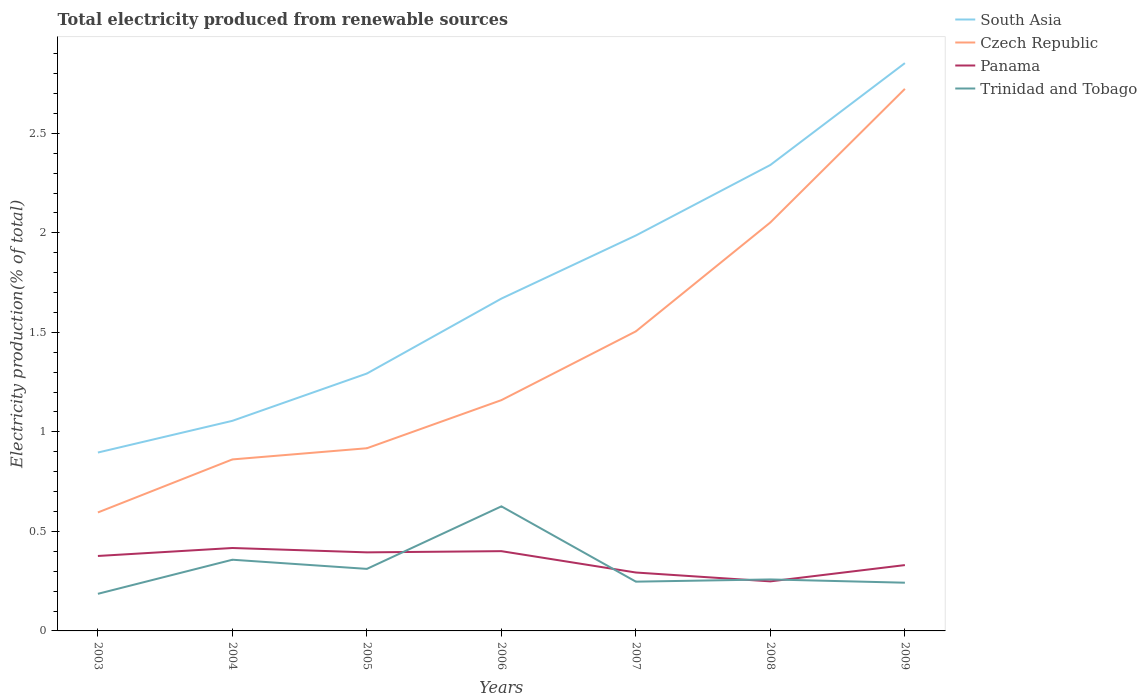How many different coloured lines are there?
Your answer should be compact. 4. Does the line corresponding to Panama intersect with the line corresponding to Czech Republic?
Provide a short and direct response. No. Across all years, what is the maximum total electricity produced in Trinidad and Tobago?
Your response must be concise. 0.19. What is the total total electricity produced in Panama in the graph?
Give a very brief answer. -0.02. What is the difference between the highest and the second highest total electricity produced in Panama?
Your answer should be compact. 0.17. Are the values on the major ticks of Y-axis written in scientific E-notation?
Provide a succinct answer. No. Does the graph contain any zero values?
Provide a succinct answer. No. Where does the legend appear in the graph?
Ensure brevity in your answer.  Top right. What is the title of the graph?
Give a very brief answer. Total electricity produced from renewable sources. What is the label or title of the X-axis?
Offer a very short reply. Years. What is the label or title of the Y-axis?
Your answer should be very brief. Electricity production(% of total). What is the Electricity production(% of total) of South Asia in 2003?
Your response must be concise. 0.9. What is the Electricity production(% of total) in Czech Republic in 2003?
Your answer should be compact. 0.6. What is the Electricity production(% of total) of Panama in 2003?
Provide a short and direct response. 0.38. What is the Electricity production(% of total) of Trinidad and Tobago in 2003?
Offer a very short reply. 0.19. What is the Electricity production(% of total) of South Asia in 2004?
Offer a very short reply. 1.06. What is the Electricity production(% of total) in Czech Republic in 2004?
Offer a very short reply. 0.86. What is the Electricity production(% of total) in Panama in 2004?
Your answer should be compact. 0.42. What is the Electricity production(% of total) in Trinidad and Tobago in 2004?
Your answer should be compact. 0.36. What is the Electricity production(% of total) of South Asia in 2005?
Your answer should be compact. 1.29. What is the Electricity production(% of total) in Czech Republic in 2005?
Provide a succinct answer. 0.92. What is the Electricity production(% of total) of Panama in 2005?
Provide a succinct answer. 0.39. What is the Electricity production(% of total) in Trinidad and Tobago in 2005?
Keep it short and to the point. 0.31. What is the Electricity production(% of total) in South Asia in 2006?
Offer a very short reply. 1.67. What is the Electricity production(% of total) in Czech Republic in 2006?
Offer a very short reply. 1.16. What is the Electricity production(% of total) in Panama in 2006?
Your answer should be very brief. 0.4. What is the Electricity production(% of total) of Trinidad and Tobago in 2006?
Your answer should be compact. 0.63. What is the Electricity production(% of total) of South Asia in 2007?
Provide a short and direct response. 1.99. What is the Electricity production(% of total) of Czech Republic in 2007?
Your answer should be compact. 1.51. What is the Electricity production(% of total) in Panama in 2007?
Ensure brevity in your answer.  0.29. What is the Electricity production(% of total) in Trinidad and Tobago in 2007?
Give a very brief answer. 0.25. What is the Electricity production(% of total) of South Asia in 2008?
Give a very brief answer. 2.34. What is the Electricity production(% of total) in Czech Republic in 2008?
Offer a terse response. 2.05. What is the Electricity production(% of total) of Panama in 2008?
Give a very brief answer. 0.25. What is the Electricity production(% of total) in Trinidad and Tobago in 2008?
Your answer should be very brief. 0.26. What is the Electricity production(% of total) in South Asia in 2009?
Offer a very short reply. 2.85. What is the Electricity production(% of total) of Czech Republic in 2009?
Give a very brief answer. 2.72. What is the Electricity production(% of total) in Panama in 2009?
Make the answer very short. 0.33. What is the Electricity production(% of total) in Trinidad and Tobago in 2009?
Offer a very short reply. 0.24. Across all years, what is the maximum Electricity production(% of total) of South Asia?
Make the answer very short. 2.85. Across all years, what is the maximum Electricity production(% of total) of Czech Republic?
Provide a short and direct response. 2.72. Across all years, what is the maximum Electricity production(% of total) of Panama?
Offer a terse response. 0.42. Across all years, what is the maximum Electricity production(% of total) of Trinidad and Tobago?
Your answer should be compact. 0.63. Across all years, what is the minimum Electricity production(% of total) of South Asia?
Your answer should be very brief. 0.9. Across all years, what is the minimum Electricity production(% of total) of Czech Republic?
Provide a short and direct response. 0.6. Across all years, what is the minimum Electricity production(% of total) in Panama?
Offer a very short reply. 0.25. Across all years, what is the minimum Electricity production(% of total) of Trinidad and Tobago?
Provide a short and direct response. 0.19. What is the total Electricity production(% of total) of South Asia in the graph?
Keep it short and to the point. 12.1. What is the total Electricity production(% of total) of Czech Republic in the graph?
Provide a short and direct response. 9.82. What is the total Electricity production(% of total) of Panama in the graph?
Your answer should be very brief. 2.46. What is the total Electricity production(% of total) of Trinidad and Tobago in the graph?
Offer a very short reply. 2.23. What is the difference between the Electricity production(% of total) of South Asia in 2003 and that in 2004?
Give a very brief answer. -0.16. What is the difference between the Electricity production(% of total) in Czech Republic in 2003 and that in 2004?
Provide a short and direct response. -0.27. What is the difference between the Electricity production(% of total) of Panama in 2003 and that in 2004?
Offer a terse response. -0.04. What is the difference between the Electricity production(% of total) in Trinidad and Tobago in 2003 and that in 2004?
Ensure brevity in your answer.  -0.17. What is the difference between the Electricity production(% of total) of South Asia in 2003 and that in 2005?
Ensure brevity in your answer.  -0.4. What is the difference between the Electricity production(% of total) of Czech Republic in 2003 and that in 2005?
Provide a short and direct response. -0.32. What is the difference between the Electricity production(% of total) of Panama in 2003 and that in 2005?
Your response must be concise. -0.02. What is the difference between the Electricity production(% of total) of Trinidad and Tobago in 2003 and that in 2005?
Ensure brevity in your answer.  -0.13. What is the difference between the Electricity production(% of total) in South Asia in 2003 and that in 2006?
Keep it short and to the point. -0.77. What is the difference between the Electricity production(% of total) of Czech Republic in 2003 and that in 2006?
Offer a terse response. -0.56. What is the difference between the Electricity production(% of total) of Panama in 2003 and that in 2006?
Offer a very short reply. -0.02. What is the difference between the Electricity production(% of total) of Trinidad and Tobago in 2003 and that in 2006?
Ensure brevity in your answer.  -0.44. What is the difference between the Electricity production(% of total) of South Asia in 2003 and that in 2007?
Your answer should be very brief. -1.09. What is the difference between the Electricity production(% of total) of Czech Republic in 2003 and that in 2007?
Offer a very short reply. -0.91. What is the difference between the Electricity production(% of total) in Panama in 2003 and that in 2007?
Provide a succinct answer. 0.08. What is the difference between the Electricity production(% of total) of Trinidad and Tobago in 2003 and that in 2007?
Provide a succinct answer. -0.06. What is the difference between the Electricity production(% of total) in South Asia in 2003 and that in 2008?
Give a very brief answer. -1.44. What is the difference between the Electricity production(% of total) in Czech Republic in 2003 and that in 2008?
Provide a succinct answer. -1.46. What is the difference between the Electricity production(% of total) of Panama in 2003 and that in 2008?
Your response must be concise. 0.13. What is the difference between the Electricity production(% of total) in Trinidad and Tobago in 2003 and that in 2008?
Give a very brief answer. -0.07. What is the difference between the Electricity production(% of total) of South Asia in 2003 and that in 2009?
Ensure brevity in your answer.  -1.96. What is the difference between the Electricity production(% of total) in Czech Republic in 2003 and that in 2009?
Provide a short and direct response. -2.13. What is the difference between the Electricity production(% of total) in Panama in 2003 and that in 2009?
Provide a succinct answer. 0.05. What is the difference between the Electricity production(% of total) of Trinidad and Tobago in 2003 and that in 2009?
Provide a succinct answer. -0.06. What is the difference between the Electricity production(% of total) of South Asia in 2004 and that in 2005?
Ensure brevity in your answer.  -0.24. What is the difference between the Electricity production(% of total) of Czech Republic in 2004 and that in 2005?
Your answer should be compact. -0.06. What is the difference between the Electricity production(% of total) in Panama in 2004 and that in 2005?
Provide a succinct answer. 0.02. What is the difference between the Electricity production(% of total) in Trinidad and Tobago in 2004 and that in 2005?
Make the answer very short. 0.05. What is the difference between the Electricity production(% of total) in South Asia in 2004 and that in 2006?
Your answer should be compact. -0.61. What is the difference between the Electricity production(% of total) in Czech Republic in 2004 and that in 2006?
Your answer should be compact. -0.3. What is the difference between the Electricity production(% of total) of Panama in 2004 and that in 2006?
Your answer should be very brief. 0.02. What is the difference between the Electricity production(% of total) in Trinidad and Tobago in 2004 and that in 2006?
Provide a short and direct response. -0.27. What is the difference between the Electricity production(% of total) in South Asia in 2004 and that in 2007?
Provide a short and direct response. -0.93. What is the difference between the Electricity production(% of total) in Czech Republic in 2004 and that in 2007?
Offer a very short reply. -0.64. What is the difference between the Electricity production(% of total) in Panama in 2004 and that in 2007?
Offer a terse response. 0.12. What is the difference between the Electricity production(% of total) in Trinidad and Tobago in 2004 and that in 2007?
Your answer should be very brief. 0.11. What is the difference between the Electricity production(% of total) in South Asia in 2004 and that in 2008?
Provide a short and direct response. -1.29. What is the difference between the Electricity production(% of total) of Czech Republic in 2004 and that in 2008?
Ensure brevity in your answer.  -1.19. What is the difference between the Electricity production(% of total) in Panama in 2004 and that in 2008?
Your answer should be very brief. 0.17. What is the difference between the Electricity production(% of total) in Trinidad and Tobago in 2004 and that in 2008?
Your answer should be very brief. 0.1. What is the difference between the Electricity production(% of total) of South Asia in 2004 and that in 2009?
Provide a short and direct response. -1.8. What is the difference between the Electricity production(% of total) in Czech Republic in 2004 and that in 2009?
Offer a terse response. -1.86. What is the difference between the Electricity production(% of total) in Panama in 2004 and that in 2009?
Make the answer very short. 0.09. What is the difference between the Electricity production(% of total) in Trinidad and Tobago in 2004 and that in 2009?
Offer a very short reply. 0.12. What is the difference between the Electricity production(% of total) of South Asia in 2005 and that in 2006?
Your response must be concise. -0.38. What is the difference between the Electricity production(% of total) in Czech Republic in 2005 and that in 2006?
Your response must be concise. -0.24. What is the difference between the Electricity production(% of total) in Panama in 2005 and that in 2006?
Make the answer very short. -0.01. What is the difference between the Electricity production(% of total) of Trinidad and Tobago in 2005 and that in 2006?
Offer a terse response. -0.31. What is the difference between the Electricity production(% of total) of South Asia in 2005 and that in 2007?
Keep it short and to the point. -0.69. What is the difference between the Electricity production(% of total) of Czech Republic in 2005 and that in 2007?
Offer a terse response. -0.59. What is the difference between the Electricity production(% of total) in Panama in 2005 and that in 2007?
Provide a succinct answer. 0.1. What is the difference between the Electricity production(% of total) in Trinidad and Tobago in 2005 and that in 2007?
Offer a terse response. 0.06. What is the difference between the Electricity production(% of total) of South Asia in 2005 and that in 2008?
Your answer should be very brief. -1.05. What is the difference between the Electricity production(% of total) of Czech Republic in 2005 and that in 2008?
Offer a very short reply. -1.13. What is the difference between the Electricity production(% of total) in Panama in 2005 and that in 2008?
Offer a terse response. 0.15. What is the difference between the Electricity production(% of total) of Trinidad and Tobago in 2005 and that in 2008?
Keep it short and to the point. 0.05. What is the difference between the Electricity production(% of total) in South Asia in 2005 and that in 2009?
Your response must be concise. -1.56. What is the difference between the Electricity production(% of total) of Czech Republic in 2005 and that in 2009?
Make the answer very short. -1.81. What is the difference between the Electricity production(% of total) in Panama in 2005 and that in 2009?
Offer a terse response. 0.06. What is the difference between the Electricity production(% of total) in Trinidad and Tobago in 2005 and that in 2009?
Your answer should be very brief. 0.07. What is the difference between the Electricity production(% of total) in South Asia in 2006 and that in 2007?
Make the answer very short. -0.32. What is the difference between the Electricity production(% of total) of Czech Republic in 2006 and that in 2007?
Provide a short and direct response. -0.35. What is the difference between the Electricity production(% of total) in Panama in 2006 and that in 2007?
Your answer should be compact. 0.11. What is the difference between the Electricity production(% of total) of Trinidad and Tobago in 2006 and that in 2007?
Provide a short and direct response. 0.38. What is the difference between the Electricity production(% of total) in South Asia in 2006 and that in 2008?
Offer a very short reply. -0.67. What is the difference between the Electricity production(% of total) in Czech Republic in 2006 and that in 2008?
Provide a succinct answer. -0.89. What is the difference between the Electricity production(% of total) of Panama in 2006 and that in 2008?
Ensure brevity in your answer.  0.15. What is the difference between the Electricity production(% of total) in Trinidad and Tobago in 2006 and that in 2008?
Offer a terse response. 0.37. What is the difference between the Electricity production(% of total) in South Asia in 2006 and that in 2009?
Your answer should be very brief. -1.18. What is the difference between the Electricity production(% of total) of Czech Republic in 2006 and that in 2009?
Offer a terse response. -1.56. What is the difference between the Electricity production(% of total) of Panama in 2006 and that in 2009?
Provide a succinct answer. 0.07. What is the difference between the Electricity production(% of total) in Trinidad and Tobago in 2006 and that in 2009?
Offer a very short reply. 0.38. What is the difference between the Electricity production(% of total) of South Asia in 2007 and that in 2008?
Offer a very short reply. -0.35. What is the difference between the Electricity production(% of total) of Czech Republic in 2007 and that in 2008?
Your answer should be compact. -0.55. What is the difference between the Electricity production(% of total) of Panama in 2007 and that in 2008?
Offer a terse response. 0.04. What is the difference between the Electricity production(% of total) in Trinidad and Tobago in 2007 and that in 2008?
Provide a succinct answer. -0.01. What is the difference between the Electricity production(% of total) in South Asia in 2007 and that in 2009?
Offer a very short reply. -0.87. What is the difference between the Electricity production(% of total) of Czech Republic in 2007 and that in 2009?
Your answer should be very brief. -1.22. What is the difference between the Electricity production(% of total) of Panama in 2007 and that in 2009?
Your answer should be very brief. -0.04. What is the difference between the Electricity production(% of total) of Trinidad and Tobago in 2007 and that in 2009?
Make the answer very short. 0.01. What is the difference between the Electricity production(% of total) in South Asia in 2008 and that in 2009?
Give a very brief answer. -0.51. What is the difference between the Electricity production(% of total) of Czech Republic in 2008 and that in 2009?
Your answer should be compact. -0.67. What is the difference between the Electricity production(% of total) of Panama in 2008 and that in 2009?
Your response must be concise. -0.08. What is the difference between the Electricity production(% of total) in Trinidad and Tobago in 2008 and that in 2009?
Offer a terse response. 0.02. What is the difference between the Electricity production(% of total) in South Asia in 2003 and the Electricity production(% of total) in Czech Republic in 2004?
Ensure brevity in your answer.  0.03. What is the difference between the Electricity production(% of total) of South Asia in 2003 and the Electricity production(% of total) of Panama in 2004?
Your answer should be very brief. 0.48. What is the difference between the Electricity production(% of total) of South Asia in 2003 and the Electricity production(% of total) of Trinidad and Tobago in 2004?
Ensure brevity in your answer.  0.54. What is the difference between the Electricity production(% of total) of Czech Republic in 2003 and the Electricity production(% of total) of Panama in 2004?
Ensure brevity in your answer.  0.18. What is the difference between the Electricity production(% of total) in Czech Republic in 2003 and the Electricity production(% of total) in Trinidad and Tobago in 2004?
Give a very brief answer. 0.24. What is the difference between the Electricity production(% of total) of Panama in 2003 and the Electricity production(% of total) of Trinidad and Tobago in 2004?
Your response must be concise. 0.02. What is the difference between the Electricity production(% of total) in South Asia in 2003 and the Electricity production(% of total) in Czech Republic in 2005?
Ensure brevity in your answer.  -0.02. What is the difference between the Electricity production(% of total) of South Asia in 2003 and the Electricity production(% of total) of Panama in 2005?
Offer a terse response. 0.5. What is the difference between the Electricity production(% of total) of South Asia in 2003 and the Electricity production(% of total) of Trinidad and Tobago in 2005?
Your answer should be compact. 0.58. What is the difference between the Electricity production(% of total) of Czech Republic in 2003 and the Electricity production(% of total) of Panama in 2005?
Ensure brevity in your answer.  0.2. What is the difference between the Electricity production(% of total) of Czech Republic in 2003 and the Electricity production(% of total) of Trinidad and Tobago in 2005?
Make the answer very short. 0.28. What is the difference between the Electricity production(% of total) in Panama in 2003 and the Electricity production(% of total) in Trinidad and Tobago in 2005?
Offer a very short reply. 0.06. What is the difference between the Electricity production(% of total) in South Asia in 2003 and the Electricity production(% of total) in Czech Republic in 2006?
Your response must be concise. -0.26. What is the difference between the Electricity production(% of total) in South Asia in 2003 and the Electricity production(% of total) in Panama in 2006?
Offer a very short reply. 0.5. What is the difference between the Electricity production(% of total) of South Asia in 2003 and the Electricity production(% of total) of Trinidad and Tobago in 2006?
Provide a short and direct response. 0.27. What is the difference between the Electricity production(% of total) of Czech Republic in 2003 and the Electricity production(% of total) of Panama in 2006?
Your answer should be very brief. 0.19. What is the difference between the Electricity production(% of total) in Czech Republic in 2003 and the Electricity production(% of total) in Trinidad and Tobago in 2006?
Provide a short and direct response. -0.03. What is the difference between the Electricity production(% of total) of Panama in 2003 and the Electricity production(% of total) of Trinidad and Tobago in 2006?
Give a very brief answer. -0.25. What is the difference between the Electricity production(% of total) of South Asia in 2003 and the Electricity production(% of total) of Czech Republic in 2007?
Give a very brief answer. -0.61. What is the difference between the Electricity production(% of total) of South Asia in 2003 and the Electricity production(% of total) of Panama in 2007?
Provide a succinct answer. 0.6. What is the difference between the Electricity production(% of total) of South Asia in 2003 and the Electricity production(% of total) of Trinidad and Tobago in 2007?
Provide a short and direct response. 0.65. What is the difference between the Electricity production(% of total) of Czech Republic in 2003 and the Electricity production(% of total) of Panama in 2007?
Your answer should be very brief. 0.3. What is the difference between the Electricity production(% of total) of Czech Republic in 2003 and the Electricity production(% of total) of Trinidad and Tobago in 2007?
Your answer should be compact. 0.35. What is the difference between the Electricity production(% of total) in Panama in 2003 and the Electricity production(% of total) in Trinidad and Tobago in 2007?
Ensure brevity in your answer.  0.13. What is the difference between the Electricity production(% of total) of South Asia in 2003 and the Electricity production(% of total) of Czech Republic in 2008?
Offer a very short reply. -1.16. What is the difference between the Electricity production(% of total) in South Asia in 2003 and the Electricity production(% of total) in Panama in 2008?
Keep it short and to the point. 0.65. What is the difference between the Electricity production(% of total) of South Asia in 2003 and the Electricity production(% of total) of Trinidad and Tobago in 2008?
Offer a terse response. 0.64. What is the difference between the Electricity production(% of total) in Czech Republic in 2003 and the Electricity production(% of total) in Panama in 2008?
Your response must be concise. 0.35. What is the difference between the Electricity production(% of total) of Czech Republic in 2003 and the Electricity production(% of total) of Trinidad and Tobago in 2008?
Make the answer very short. 0.34. What is the difference between the Electricity production(% of total) in Panama in 2003 and the Electricity production(% of total) in Trinidad and Tobago in 2008?
Your answer should be compact. 0.12. What is the difference between the Electricity production(% of total) in South Asia in 2003 and the Electricity production(% of total) in Czech Republic in 2009?
Your response must be concise. -1.83. What is the difference between the Electricity production(% of total) of South Asia in 2003 and the Electricity production(% of total) of Panama in 2009?
Your response must be concise. 0.57. What is the difference between the Electricity production(% of total) in South Asia in 2003 and the Electricity production(% of total) in Trinidad and Tobago in 2009?
Keep it short and to the point. 0.65. What is the difference between the Electricity production(% of total) in Czech Republic in 2003 and the Electricity production(% of total) in Panama in 2009?
Your answer should be compact. 0.26. What is the difference between the Electricity production(% of total) in Czech Republic in 2003 and the Electricity production(% of total) in Trinidad and Tobago in 2009?
Your response must be concise. 0.35. What is the difference between the Electricity production(% of total) of Panama in 2003 and the Electricity production(% of total) of Trinidad and Tobago in 2009?
Offer a terse response. 0.13. What is the difference between the Electricity production(% of total) of South Asia in 2004 and the Electricity production(% of total) of Czech Republic in 2005?
Keep it short and to the point. 0.14. What is the difference between the Electricity production(% of total) in South Asia in 2004 and the Electricity production(% of total) in Panama in 2005?
Provide a succinct answer. 0.66. What is the difference between the Electricity production(% of total) in South Asia in 2004 and the Electricity production(% of total) in Trinidad and Tobago in 2005?
Provide a short and direct response. 0.74. What is the difference between the Electricity production(% of total) of Czech Republic in 2004 and the Electricity production(% of total) of Panama in 2005?
Offer a terse response. 0.47. What is the difference between the Electricity production(% of total) in Czech Republic in 2004 and the Electricity production(% of total) in Trinidad and Tobago in 2005?
Provide a succinct answer. 0.55. What is the difference between the Electricity production(% of total) of Panama in 2004 and the Electricity production(% of total) of Trinidad and Tobago in 2005?
Give a very brief answer. 0.1. What is the difference between the Electricity production(% of total) in South Asia in 2004 and the Electricity production(% of total) in Czech Republic in 2006?
Your answer should be very brief. -0.1. What is the difference between the Electricity production(% of total) of South Asia in 2004 and the Electricity production(% of total) of Panama in 2006?
Make the answer very short. 0.65. What is the difference between the Electricity production(% of total) in South Asia in 2004 and the Electricity production(% of total) in Trinidad and Tobago in 2006?
Your answer should be very brief. 0.43. What is the difference between the Electricity production(% of total) in Czech Republic in 2004 and the Electricity production(% of total) in Panama in 2006?
Provide a short and direct response. 0.46. What is the difference between the Electricity production(% of total) in Czech Republic in 2004 and the Electricity production(% of total) in Trinidad and Tobago in 2006?
Ensure brevity in your answer.  0.24. What is the difference between the Electricity production(% of total) of Panama in 2004 and the Electricity production(% of total) of Trinidad and Tobago in 2006?
Offer a terse response. -0.21. What is the difference between the Electricity production(% of total) in South Asia in 2004 and the Electricity production(% of total) in Czech Republic in 2007?
Provide a succinct answer. -0.45. What is the difference between the Electricity production(% of total) of South Asia in 2004 and the Electricity production(% of total) of Panama in 2007?
Ensure brevity in your answer.  0.76. What is the difference between the Electricity production(% of total) in South Asia in 2004 and the Electricity production(% of total) in Trinidad and Tobago in 2007?
Your answer should be very brief. 0.81. What is the difference between the Electricity production(% of total) in Czech Republic in 2004 and the Electricity production(% of total) in Panama in 2007?
Provide a short and direct response. 0.57. What is the difference between the Electricity production(% of total) in Czech Republic in 2004 and the Electricity production(% of total) in Trinidad and Tobago in 2007?
Give a very brief answer. 0.61. What is the difference between the Electricity production(% of total) in Panama in 2004 and the Electricity production(% of total) in Trinidad and Tobago in 2007?
Keep it short and to the point. 0.17. What is the difference between the Electricity production(% of total) in South Asia in 2004 and the Electricity production(% of total) in Czech Republic in 2008?
Make the answer very short. -1. What is the difference between the Electricity production(% of total) of South Asia in 2004 and the Electricity production(% of total) of Panama in 2008?
Provide a succinct answer. 0.81. What is the difference between the Electricity production(% of total) in South Asia in 2004 and the Electricity production(% of total) in Trinidad and Tobago in 2008?
Your answer should be very brief. 0.8. What is the difference between the Electricity production(% of total) in Czech Republic in 2004 and the Electricity production(% of total) in Panama in 2008?
Provide a succinct answer. 0.61. What is the difference between the Electricity production(% of total) of Czech Republic in 2004 and the Electricity production(% of total) of Trinidad and Tobago in 2008?
Offer a very short reply. 0.6. What is the difference between the Electricity production(% of total) of Panama in 2004 and the Electricity production(% of total) of Trinidad and Tobago in 2008?
Your answer should be very brief. 0.16. What is the difference between the Electricity production(% of total) in South Asia in 2004 and the Electricity production(% of total) in Czech Republic in 2009?
Give a very brief answer. -1.67. What is the difference between the Electricity production(% of total) in South Asia in 2004 and the Electricity production(% of total) in Panama in 2009?
Provide a succinct answer. 0.72. What is the difference between the Electricity production(% of total) of South Asia in 2004 and the Electricity production(% of total) of Trinidad and Tobago in 2009?
Your response must be concise. 0.81. What is the difference between the Electricity production(% of total) of Czech Republic in 2004 and the Electricity production(% of total) of Panama in 2009?
Provide a succinct answer. 0.53. What is the difference between the Electricity production(% of total) of Czech Republic in 2004 and the Electricity production(% of total) of Trinidad and Tobago in 2009?
Offer a terse response. 0.62. What is the difference between the Electricity production(% of total) in Panama in 2004 and the Electricity production(% of total) in Trinidad and Tobago in 2009?
Keep it short and to the point. 0.17. What is the difference between the Electricity production(% of total) of South Asia in 2005 and the Electricity production(% of total) of Czech Republic in 2006?
Provide a short and direct response. 0.13. What is the difference between the Electricity production(% of total) in South Asia in 2005 and the Electricity production(% of total) in Panama in 2006?
Provide a short and direct response. 0.89. What is the difference between the Electricity production(% of total) of South Asia in 2005 and the Electricity production(% of total) of Trinidad and Tobago in 2006?
Ensure brevity in your answer.  0.67. What is the difference between the Electricity production(% of total) of Czech Republic in 2005 and the Electricity production(% of total) of Panama in 2006?
Your response must be concise. 0.52. What is the difference between the Electricity production(% of total) of Czech Republic in 2005 and the Electricity production(% of total) of Trinidad and Tobago in 2006?
Offer a very short reply. 0.29. What is the difference between the Electricity production(% of total) in Panama in 2005 and the Electricity production(% of total) in Trinidad and Tobago in 2006?
Offer a terse response. -0.23. What is the difference between the Electricity production(% of total) in South Asia in 2005 and the Electricity production(% of total) in Czech Republic in 2007?
Ensure brevity in your answer.  -0.21. What is the difference between the Electricity production(% of total) in South Asia in 2005 and the Electricity production(% of total) in Panama in 2007?
Make the answer very short. 1. What is the difference between the Electricity production(% of total) of South Asia in 2005 and the Electricity production(% of total) of Trinidad and Tobago in 2007?
Offer a very short reply. 1.05. What is the difference between the Electricity production(% of total) of Czech Republic in 2005 and the Electricity production(% of total) of Panama in 2007?
Offer a terse response. 0.62. What is the difference between the Electricity production(% of total) of Czech Republic in 2005 and the Electricity production(% of total) of Trinidad and Tobago in 2007?
Provide a succinct answer. 0.67. What is the difference between the Electricity production(% of total) in Panama in 2005 and the Electricity production(% of total) in Trinidad and Tobago in 2007?
Offer a terse response. 0.15. What is the difference between the Electricity production(% of total) of South Asia in 2005 and the Electricity production(% of total) of Czech Republic in 2008?
Your response must be concise. -0.76. What is the difference between the Electricity production(% of total) in South Asia in 2005 and the Electricity production(% of total) in Panama in 2008?
Give a very brief answer. 1.04. What is the difference between the Electricity production(% of total) of South Asia in 2005 and the Electricity production(% of total) of Trinidad and Tobago in 2008?
Keep it short and to the point. 1.03. What is the difference between the Electricity production(% of total) in Czech Republic in 2005 and the Electricity production(% of total) in Panama in 2008?
Your answer should be compact. 0.67. What is the difference between the Electricity production(% of total) of Czech Republic in 2005 and the Electricity production(% of total) of Trinidad and Tobago in 2008?
Give a very brief answer. 0.66. What is the difference between the Electricity production(% of total) of Panama in 2005 and the Electricity production(% of total) of Trinidad and Tobago in 2008?
Provide a succinct answer. 0.14. What is the difference between the Electricity production(% of total) of South Asia in 2005 and the Electricity production(% of total) of Czech Republic in 2009?
Keep it short and to the point. -1.43. What is the difference between the Electricity production(% of total) in South Asia in 2005 and the Electricity production(% of total) in Panama in 2009?
Give a very brief answer. 0.96. What is the difference between the Electricity production(% of total) in South Asia in 2005 and the Electricity production(% of total) in Trinidad and Tobago in 2009?
Provide a succinct answer. 1.05. What is the difference between the Electricity production(% of total) in Czech Republic in 2005 and the Electricity production(% of total) in Panama in 2009?
Your answer should be compact. 0.59. What is the difference between the Electricity production(% of total) in Czech Republic in 2005 and the Electricity production(% of total) in Trinidad and Tobago in 2009?
Offer a terse response. 0.68. What is the difference between the Electricity production(% of total) of Panama in 2005 and the Electricity production(% of total) of Trinidad and Tobago in 2009?
Make the answer very short. 0.15. What is the difference between the Electricity production(% of total) of South Asia in 2006 and the Electricity production(% of total) of Czech Republic in 2007?
Give a very brief answer. 0.16. What is the difference between the Electricity production(% of total) of South Asia in 2006 and the Electricity production(% of total) of Panama in 2007?
Give a very brief answer. 1.38. What is the difference between the Electricity production(% of total) of South Asia in 2006 and the Electricity production(% of total) of Trinidad and Tobago in 2007?
Your response must be concise. 1.42. What is the difference between the Electricity production(% of total) of Czech Republic in 2006 and the Electricity production(% of total) of Panama in 2007?
Your response must be concise. 0.87. What is the difference between the Electricity production(% of total) of Czech Republic in 2006 and the Electricity production(% of total) of Trinidad and Tobago in 2007?
Provide a succinct answer. 0.91. What is the difference between the Electricity production(% of total) of Panama in 2006 and the Electricity production(% of total) of Trinidad and Tobago in 2007?
Your answer should be very brief. 0.15. What is the difference between the Electricity production(% of total) in South Asia in 2006 and the Electricity production(% of total) in Czech Republic in 2008?
Provide a short and direct response. -0.38. What is the difference between the Electricity production(% of total) of South Asia in 2006 and the Electricity production(% of total) of Panama in 2008?
Offer a terse response. 1.42. What is the difference between the Electricity production(% of total) of South Asia in 2006 and the Electricity production(% of total) of Trinidad and Tobago in 2008?
Offer a very short reply. 1.41. What is the difference between the Electricity production(% of total) in Czech Republic in 2006 and the Electricity production(% of total) in Panama in 2008?
Give a very brief answer. 0.91. What is the difference between the Electricity production(% of total) in Czech Republic in 2006 and the Electricity production(% of total) in Trinidad and Tobago in 2008?
Ensure brevity in your answer.  0.9. What is the difference between the Electricity production(% of total) of Panama in 2006 and the Electricity production(% of total) of Trinidad and Tobago in 2008?
Offer a very short reply. 0.14. What is the difference between the Electricity production(% of total) of South Asia in 2006 and the Electricity production(% of total) of Czech Republic in 2009?
Offer a very short reply. -1.05. What is the difference between the Electricity production(% of total) in South Asia in 2006 and the Electricity production(% of total) in Panama in 2009?
Offer a terse response. 1.34. What is the difference between the Electricity production(% of total) of South Asia in 2006 and the Electricity production(% of total) of Trinidad and Tobago in 2009?
Provide a short and direct response. 1.43. What is the difference between the Electricity production(% of total) of Czech Republic in 2006 and the Electricity production(% of total) of Panama in 2009?
Your answer should be very brief. 0.83. What is the difference between the Electricity production(% of total) in Czech Republic in 2006 and the Electricity production(% of total) in Trinidad and Tobago in 2009?
Give a very brief answer. 0.92. What is the difference between the Electricity production(% of total) in Panama in 2006 and the Electricity production(% of total) in Trinidad and Tobago in 2009?
Make the answer very short. 0.16. What is the difference between the Electricity production(% of total) in South Asia in 2007 and the Electricity production(% of total) in Czech Republic in 2008?
Keep it short and to the point. -0.07. What is the difference between the Electricity production(% of total) in South Asia in 2007 and the Electricity production(% of total) in Panama in 2008?
Your response must be concise. 1.74. What is the difference between the Electricity production(% of total) in South Asia in 2007 and the Electricity production(% of total) in Trinidad and Tobago in 2008?
Offer a terse response. 1.73. What is the difference between the Electricity production(% of total) of Czech Republic in 2007 and the Electricity production(% of total) of Panama in 2008?
Offer a very short reply. 1.26. What is the difference between the Electricity production(% of total) in Czech Republic in 2007 and the Electricity production(% of total) in Trinidad and Tobago in 2008?
Provide a succinct answer. 1.25. What is the difference between the Electricity production(% of total) of Panama in 2007 and the Electricity production(% of total) of Trinidad and Tobago in 2008?
Offer a terse response. 0.03. What is the difference between the Electricity production(% of total) of South Asia in 2007 and the Electricity production(% of total) of Czech Republic in 2009?
Keep it short and to the point. -0.74. What is the difference between the Electricity production(% of total) of South Asia in 2007 and the Electricity production(% of total) of Panama in 2009?
Make the answer very short. 1.66. What is the difference between the Electricity production(% of total) of South Asia in 2007 and the Electricity production(% of total) of Trinidad and Tobago in 2009?
Your answer should be compact. 1.74. What is the difference between the Electricity production(% of total) in Czech Republic in 2007 and the Electricity production(% of total) in Panama in 2009?
Your answer should be very brief. 1.17. What is the difference between the Electricity production(% of total) of Czech Republic in 2007 and the Electricity production(% of total) of Trinidad and Tobago in 2009?
Provide a short and direct response. 1.26. What is the difference between the Electricity production(% of total) in Panama in 2007 and the Electricity production(% of total) in Trinidad and Tobago in 2009?
Your answer should be compact. 0.05. What is the difference between the Electricity production(% of total) of South Asia in 2008 and the Electricity production(% of total) of Czech Republic in 2009?
Your answer should be very brief. -0.38. What is the difference between the Electricity production(% of total) in South Asia in 2008 and the Electricity production(% of total) in Panama in 2009?
Your response must be concise. 2.01. What is the difference between the Electricity production(% of total) in South Asia in 2008 and the Electricity production(% of total) in Trinidad and Tobago in 2009?
Your response must be concise. 2.1. What is the difference between the Electricity production(% of total) in Czech Republic in 2008 and the Electricity production(% of total) in Panama in 2009?
Offer a very short reply. 1.72. What is the difference between the Electricity production(% of total) of Czech Republic in 2008 and the Electricity production(% of total) of Trinidad and Tobago in 2009?
Your answer should be very brief. 1.81. What is the difference between the Electricity production(% of total) of Panama in 2008 and the Electricity production(% of total) of Trinidad and Tobago in 2009?
Ensure brevity in your answer.  0.01. What is the average Electricity production(% of total) of South Asia per year?
Make the answer very short. 1.73. What is the average Electricity production(% of total) in Czech Republic per year?
Ensure brevity in your answer.  1.4. What is the average Electricity production(% of total) of Panama per year?
Keep it short and to the point. 0.35. What is the average Electricity production(% of total) of Trinidad and Tobago per year?
Provide a short and direct response. 0.32. In the year 2003, what is the difference between the Electricity production(% of total) of South Asia and Electricity production(% of total) of Czech Republic?
Your answer should be compact. 0.3. In the year 2003, what is the difference between the Electricity production(% of total) in South Asia and Electricity production(% of total) in Panama?
Your response must be concise. 0.52. In the year 2003, what is the difference between the Electricity production(% of total) in South Asia and Electricity production(% of total) in Trinidad and Tobago?
Make the answer very short. 0.71. In the year 2003, what is the difference between the Electricity production(% of total) in Czech Republic and Electricity production(% of total) in Panama?
Offer a terse response. 0.22. In the year 2003, what is the difference between the Electricity production(% of total) of Czech Republic and Electricity production(% of total) of Trinidad and Tobago?
Your answer should be compact. 0.41. In the year 2003, what is the difference between the Electricity production(% of total) in Panama and Electricity production(% of total) in Trinidad and Tobago?
Provide a short and direct response. 0.19. In the year 2004, what is the difference between the Electricity production(% of total) in South Asia and Electricity production(% of total) in Czech Republic?
Your response must be concise. 0.19. In the year 2004, what is the difference between the Electricity production(% of total) in South Asia and Electricity production(% of total) in Panama?
Provide a short and direct response. 0.64. In the year 2004, what is the difference between the Electricity production(% of total) of South Asia and Electricity production(% of total) of Trinidad and Tobago?
Make the answer very short. 0.7. In the year 2004, what is the difference between the Electricity production(% of total) in Czech Republic and Electricity production(% of total) in Panama?
Provide a short and direct response. 0.45. In the year 2004, what is the difference between the Electricity production(% of total) of Czech Republic and Electricity production(% of total) of Trinidad and Tobago?
Your answer should be very brief. 0.5. In the year 2004, what is the difference between the Electricity production(% of total) of Panama and Electricity production(% of total) of Trinidad and Tobago?
Your answer should be very brief. 0.06. In the year 2005, what is the difference between the Electricity production(% of total) of South Asia and Electricity production(% of total) of Czech Republic?
Provide a short and direct response. 0.38. In the year 2005, what is the difference between the Electricity production(% of total) of South Asia and Electricity production(% of total) of Panama?
Give a very brief answer. 0.9. In the year 2005, what is the difference between the Electricity production(% of total) in South Asia and Electricity production(% of total) in Trinidad and Tobago?
Keep it short and to the point. 0.98. In the year 2005, what is the difference between the Electricity production(% of total) in Czech Republic and Electricity production(% of total) in Panama?
Your answer should be very brief. 0.52. In the year 2005, what is the difference between the Electricity production(% of total) in Czech Republic and Electricity production(% of total) in Trinidad and Tobago?
Ensure brevity in your answer.  0.61. In the year 2005, what is the difference between the Electricity production(% of total) in Panama and Electricity production(% of total) in Trinidad and Tobago?
Your response must be concise. 0.08. In the year 2006, what is the difference between the Electricity production(% of total) in South Asia and Electricity production(% of total) in Czech Republic?
Offer a terse response. 0.51. In the year 2006, what is the difference between the Electricity production(% of total) in South Asia and Electricity production(% of total) in Panama?
Your answer should be compact. 1.27. In the year 2006, what is the difference between the Electricity production(% of total) in South Asia and Electricity production(% of total) in Trinidad and Tobago?
Offer a terse response. 1.04. In the year 2006, what is the difference between the Electricity production(% of total) in Czech Republic and Electricity production(% of total) in Panama?
Your response must be concise. 0.76. In the year 2006, what is the difference between the Electricity production(% of total) of Czech Republic and Electricity production(% of total) of Trinidad and Tobago?
Your answer should be compact. 0.53. In the year 2006, what is the difference between the Electricity production(% of total) in Panama and Electricity production(% of total) in Trinidad and Tobago?
Offer a terse response. -0.23. In the year 2007, what is the difference between the Electricity production(% of total) in South Asia and Electricity production(% of total) in Czech Republic?
Provide a short and direct response. 0.48. In the year 2007, what is the difference between the Electricity production(% of total) in South Asia and Electricity production(% of total) in Panama?
Offer a very short reply. 1.69. In the year 2007, what is the difference between the Electricity production(% of total) of South Asia and Electricity production(% of total) of Trinidad and Tobago?
Offer a terse response. 1.74. In the year 2007, what is the difference between the Electricity production(% of total) in Czech Republic and Electricity production(% of total) in Panama?
Keep it short and to the point. 1.21. In the year 2007, what is the difference between the Electricity production(% of total) of Czech Republic and Electricity production(% of total) of Trinidad and Tobago?
Keep it short and to the point. 1.26. In the year 2007, what is the difference between the Electricity production(% of total) of Panama and Electricity production(% of total) of Trinidad and Tobago?
Offer a terse response. 0.05. In the year 2008, what is the difference between the Electricity production(% of total) in South Asia and Electricity production(% of total) in Czech Republic?
Give a very brief answer. 0.29. In the year 2008, what is the difference between the Electricity production(% of total) in South Asia and Electricity production(% of total) in Panama?
Offer a terse response. 2.09. In the year 2008, what is the difference between the Electricity production(% of total) in South Asia and Electricity production(% of total) in Trinidad and Tobago?
Offer a terse response. 2.08. In the year 2008, what is the difference between the Electricity production(% of total) of Czech Republic and Electricity production(% of total) of Panama?
Provide a short and direct response. 1.8. In the year 2008, what is the difference between the Electricity production(% of total) of Czech Republic and Electricity production(% of total) of Trinidad and Tobago?
Make the answer very short. 1.79. In the year 2008, what is the difference between the Electricity production(% of total) of Panama and Electricity production(% of total) of Trinidad and Tobago?
Offer a very short reply. -0.01. In the year 2009, what is the difference between the Electricity production(% of total) of South Asia and Electricity production(% of total) of Czech Republic?
Provide a short and direct response. 0.13. In the year 2009, what is the difference between the Electricity production(% of total) of South Asia and Electricity production(% of total) of Panama?
Offer a very short reply. 2.52. In the year 2009, what is the difference between the Electricity production(% of total) in South Asia and Electricity production(% of total) in Trinidad and Tobago?
Your answer should be compact. 2.61. In the year 2009, what is the difference between the Electricity production(% of total) of Czech Republic and Electricity production(% of total) of Panama?
Provide a succinct answer. 2.39. In the year 2009, what is the difference between the Electricity production(% of total) of Czech Republic and Electricity production(% of total) of Trinidad and Tobago?
Offer a terse response. 2.48. In the year 2009, what is the difference between the Electricity production(% of total) in Panama and Electricity production(% of total) in Trinidad and Tobago?
Give a very brief answer. 0.09. What is the ratio of the Electricity production(% of total) in South Asia in 2003 to that in 2004?
Your answer should be compact. 0.85. What is the ratio of the Electricity production(% of total) in Czech Republic in 2003 to that in 2004?
Keep it short and to the point. 0.69. What is the ratio of the Electricity production(% of total) of Panama in 2003 to that in 2004?
Your response must be concise. 0.9. What is the ratio of the Electricity production(% of total) in Trinidad and Tobago in 2003 to that in 2004?
Provide a succinct answer. 0.52. What is the ratio of the Electricity production(% of total) of South Asia in 2003 to that in 2005?
Your answer should be very brief. 0.69. What is the ratio of the Electricity production(% of total) in Czech Republic in 2003 to that in 2005?
Provide a short and direct response. 0.65. What is the ratio of the Electricity production(% of total) in Panama in 2003 to that in 2005?
Your response must be concise. 0.95. What is the ratio of the Electricity production(% of total) in Trinidad and Tobago in 2003 to that in 2005?
Offer a very short reply. 0.6. What is the ratio of the Electricity production(% of total) in South Asia in 2003 to that in 2006?
Your response must be concise. 0.54. What is the ratio of the Electricity production(% of total) of Czech Republic in 2003 to that in 2006?
Make the answer very short. 0.51. What is the ratio of the Electricity production(% of total) of Panama in 2003 to that in 2006?
Make the answer very short. 0.94. What is the ratio of the Electricity production(% of total) in Trinidad and Tobago in 2003 to that in 2006?
Make the answer very short. 0.3. What is the ratio of the Electricity production(% of total) in South Asia in 2003 to that in 2007?
Offer a very short reply. 0.45. What is the ratio of the Electricity production(% of total) in Czech Republic in 2003 to that in 2007?
Keep it short and to the point. 0.4. What is the ratio of the Electricity production(% of total) of Panama in 2003 to that in 2007?
Your answer should be compact. 1.28. What is the ratio of the Electricity production(% of total) of Trinidad and Tobago in 2003 to that in 2007?
Provide a succinct answer. 0.75. What is the ratio of the Electricity production(% of total) in South Asia in 2003 to that in 2008?
Your answer should be very brief. 0.38. What is the ratio of the Electricity production(% of total) in Czech Republic in 2003 to that in 2008?
Your response must be concise. 0.29. What is the ratio of the Electricity production(% of total) in Panama in 2003 to that in 2008?
Give a very brief answer. 1.51. What is the ratio of the Electricity production(% of total) in Trinidad and Tobago in 2003 to that in 2008?
Offer a very short reply. 0.72. What is the ratio of the Electricity production(% of total) of South Asia in 2003 to that in 2009?
Ensure brevity in your answer.  0.31. What is the ratio of the Electricity production(% of total) of Czech Republic in 2003 to that in 2009?
Offer a very short reply. 0.22. What is the ratio of the Electricity production(% of total) of Panama in 2003 to that in 2009?
Make the answer very short. 1.14. What is the ratio of the Electricity production(% of total) in Trinidad and Tobago in 2003 to that in 2009?
Your answer should be compact. 0.77. What is the ratio of the Electricity production(% of total) in South Asia in 2004 to that in 2005?
Give a very brief answer. 0.82. What is the ratio of the Electricity production(% of total) in Czech Republic in 2004 to that in 2005?
Provide a succinct answer. 0.94. What is the ratio of the Electricity production(% of total) in Panama in 2004 to that in 2005?
Provide a short and direct response. 1.06. What is the ratio of the Electricity production(% of total) of Trinidad and Tobago in 2004 to that in 2005?
Make the answer very short. 1.15. What is the ratio of the Electricity production(% of total) of South Asia in 2004 to that in 2006?
Give a very brief answer. 0.63. What is the ratio of the Electricity production(% of total) in Czech Republic in 2004 to that in 2006?
Provide a short and direct response. 0.74. What is the ratio of the Electricity production(% of total) of Panama in 2004 to that in 2006?
Ensure brevity in your answer.  1.04. What is the ratio of the Electricity production(% of total) in Trinidad and Tobago in 2004 to that in 2006?
Your answer should be very brief. 0.57. What is the ratio of the Electricity production(% of total) of South Asia in 2004 to that in 2007?
Provide a short and direct response. 0.53. What is the ratio of the Electricity production(% of total) in Czech Republic in 2004 to that in 2007?
Your answer should be compact. 0.57. What is the ratio of the Electricity production(% of total) in Panama in 2004 to that in 2007?
Provide a short and direct response. 1.42. What is the ratio of the Electricity production(% of total) of Trinidad and Tobago in 2004 to that in 2007?
Ensure brevity in your answer.  1.45. What is the ratio of the Electricity production(% of total) in South Asia in 2004 to that in 2008?
Give a very brief answer. 0.45. What is the ratio of the Electricity production(% of total) of Czech Republic in 2004 to that in 2008?
Your answer should be very brief. 0.42. What is the ratio of the Electricity production(% of total) in Panama in 2004 to that in 2008?
Give a very brief answer. 1.67. What is the ratio of the Electricity production(% of total) of Trinidad and Tobago in 2004 to that in 2008?
Offer a terse response. 1.38. What is the ratio of the Electricity production(% of total) in South Asia in 2004 to that in 2009?
Provide a short and direct response. 0.37. What is the ratio of the Electricity production(% of total) in Czech Republic in 2004 to that in 2009?
Offer a very short reply. 0.32. What is the ratio of the Electricity production(% of total) of Panama in 2004 to that in 2009?
Give a very brief answer. 1.26. What is the ratio of the Electricity production(% of total) of Trinidad and Tobago in 2004 to that in 2009?
Offer a very short reply. 1.48. What is the ratio of the Electricity production(% of total) of South Asia in 2005 to that in 2006?
Your answer should be compact. 0.77. What is the ratio of the Electricity production(% of total) in Czech Republic in 2005 to that in 2006?
Provide a short and direct response. 0.79. What is the ratio of the Electricity production(% of total) of Panama in 2005 to that in 2006?
Offer a very short reply. 0.98. What is the ratio of the Electricity production(% of total) in Trinidad and Tobago in 2005 to that in 2006?
Give a very brief answer. 0.5. What is the ratio of the Electricity production(% of total) in South Asia in 2005 to that in 2007?
Your response must be concise. 0.65. What is the ratio of the Electricity production(% of total) in Czech Republic in 2005 to that in 2007?
Make the answer very short. 0.61. What is the ratio of the Electricity production(% of total) in Panama in 2005 to that in 2007?
Make the answer very short. 1.35. What is the ratio of the Electricity production(% of total) of Trinidad and Tobago in 2005 to that in 2007?
Ensure brevity in your answer.  1.26. What is the ratio of the Electricity production(% of total) in South Asia in 2005 to that in 2008?
Make the answer very short. 0.55. What is the ratio of the Electricity production(% of total) of Czech Republic in 2005 to that in 2008?
Make the answer very short. 0.45. What is the ratio of the Electricity production(% of total) of Panama in 2005 to that in 2008?
Your response must be concise. 1.59. What is the ratio of the Electricity production(% of total) in Trinidad and Tobago in 2005 to that in 2008?
Provide a short and direct response. 1.2. What is the ratio of the Electricity production(% of total) in South Asia in 2005 to that in 2009?
Your response must be concise. 0.45. What is the ratio of the Electricity production(% of total) of Czech Republic in 2005 to that in 2009?
Offer a very short reply. 0.34. What is the ratio of the Electricity production(% of total) in Panama in 2005 to that in 2009?
Offer a very short reply. 1.19. What is the ratio of the Electricity production(% of total) in Trinidad and Tobago in 2005 to that in 2009?
Make the answer very short. 1.29. What is the ratio of the Electricity production(% of total) of South Asia in 2006 to that in 2007?
Keep it short and to the point. 0.84. What is the ratio of the Electricity production(% of total) of Czech Republic in 2006 to that in 2007?
Ensure brevity in your answer.  0.77. What is the ratio of the Electricity production(% of total) in Panama in 2006 to that in 2007?
Your answer should be compact. 1.37. What is the ratio of the Electricity production(% of total) in Trinidad and Tobago in 2006 to that in 2007?
Offer a very short reply. 2.53. What is the ratio of the Electricity production(% of total) of South Asia in 2006 to that in 2008?
Make the answer very short. 0.71. What is the ratio of the Electricity production(% of total) in Czech Republic in 2006 to that in 2008?
Make the answer very short. 0.56. What is the ratio of the Electricity production(% of total) of Panama in 2006 to that in 2008?
Your answer should be very brief. 1.61. What is the ratio of the Electricity production(% of total) in Trinidad and Tobago in 2006 to that in 2008?
Give a very brief answer. 2.42. What is the ratio of the Electricity production(% of total) of South Asia in 2006 to that in 2009?
Ensure brevity in your answer.  0.59. What is the ratio of the Electricity production(% of total) in Czech Republic in 2006 to that in 2009?
Keep it short and to the point. 0.43. What is the ratio of the Electricity production(% of total) of Panama in 2006 to that in 2009?
Give a very brief answer. 1.21. What is the ratio of the Electricity production(% of total) in Trinidad and Tobago in 2006 to that in 2009?
Your response must be concise. 2.58. What is the ratio of the Electricity production(% of total) of South Asia in 2007 to that in 2008?
Make the answer very short. 0.85. What is the ratio of the Electricity production(% of total) in Czech Republic in 2007 to that in 2008?
Your response must be concise. 0.73. What is the ratio of the Electricity production(% of total) of Panama in 2007 to that in 2008?
Provide a short and direct response. 1.18. What is the ratio of the Electricity production(% of total) of Trinidad and Tobago in 2007 to that in 2008?
Your answer should be compact. 0.96. What is the ratio of the Electricity production(% of total) in South Asia in 2007 to that in 2009?
Your answer should be compact. 0.7. What is the ratio of the Electricity production(% of total) of Czech Republic in 2007 to that in 2009?
Your answer should be compact. 0.55. What is the ratio of the Electricity production(% of total) of Panama in 2007 to that in 2009?
Your answer should be compact. 0.89. What is the ratio of the Electricity production(% of total) of Trinidad and Tobago in 2007 to that in 2009?
Ensure brevity in your answer.  1.02. What is the ratio of the Electricity production(% of total) of South Asia in 2008 to that in 2009?
Your answer should be compact. 0.82. What is the ratio of the Electricity production(% of total) of Czech Republic in 2008 to that in 2009?
Offer a terse response. 0.75. What is the ratio of the Electricity production(% of total) in Panama in 2008 to that in 2009?
Provide a short and direct response. 0.75. What is the ratio of the Electricity production(% of total) of Trinidad and Tobago in 2008 to that in 2009?
Give a very brief answer. 1.07. What is the difference between the highest and the second highest Electricity production(% of total) of South Asia?
Make the answer very short. 0.51. What is the difference between the highest and the second highest Electricity production(% of total) in Czech Republic?
Your answer should be very brief. 0.67. What is the difference between the highest and the second highest Electricity production(% of total) of Panama?
Provide a succinct answer. 0.02. What is the difference between the highest and the second highest Electricity production(% of total) in Trinidad and Tobago?
Your answer should be compact. 0.27. What is the difference between the highest and the lowest Electricity production(% of total) of South Asia?
Your answer should be compact. 1.96. What is the difference between the highest and the lowest Electricity production(% of total) of Czech Republic?
Provide a short and direct response. 2.13. What is the difference between the highest and the lowest Electricity production(% of total) in Panama?
Make the answer very short. 0.17. What is the difference between the highest and the lowest Electricity production(% of total) in Trinidad and Tobago?
Your answer should be very brief. 0.44. 